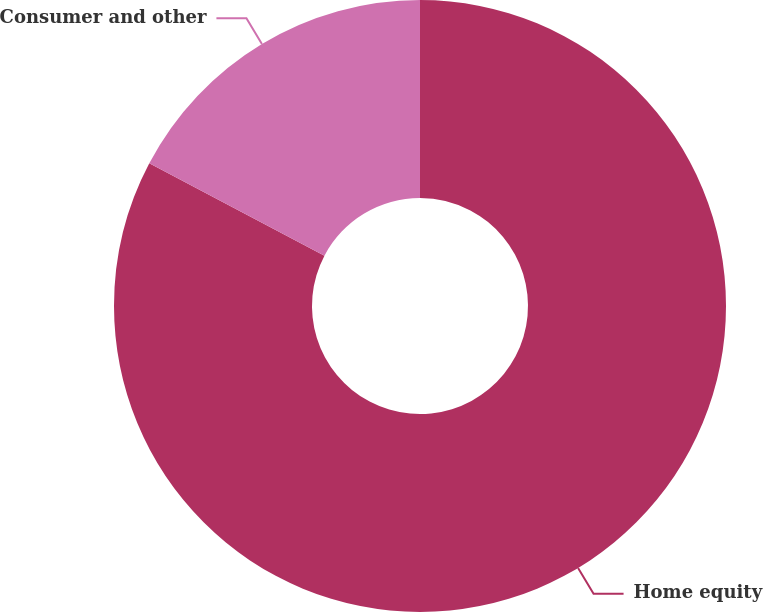Convert chart to OTSL. <chart><loc_0><loc_0><loc_500><loc_500><pie_chart><fcel>Home equity<fcel>Consumer and other<nl><fcel>82.72%<fcel>17.28%<nl></chart> 